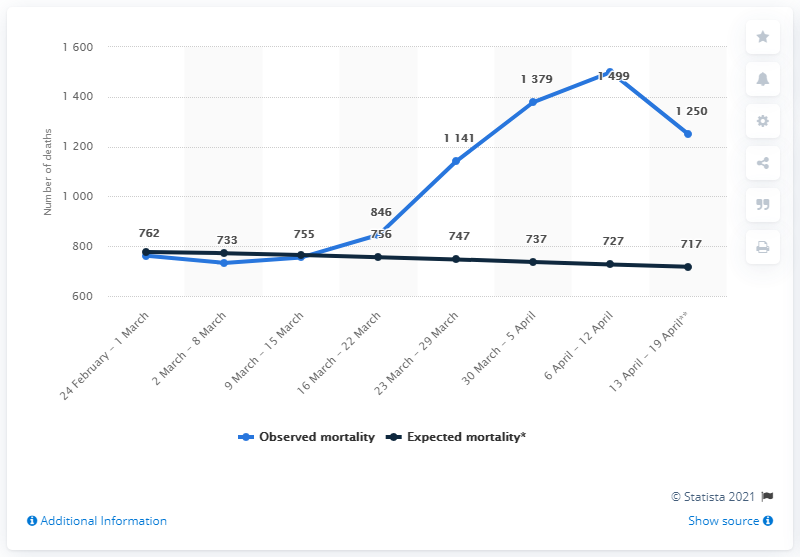Mention a couple of crucial points in this snapshot. According to the predictions made over the last five years, the number of deaths that should have occurred during that week should have been 727. 